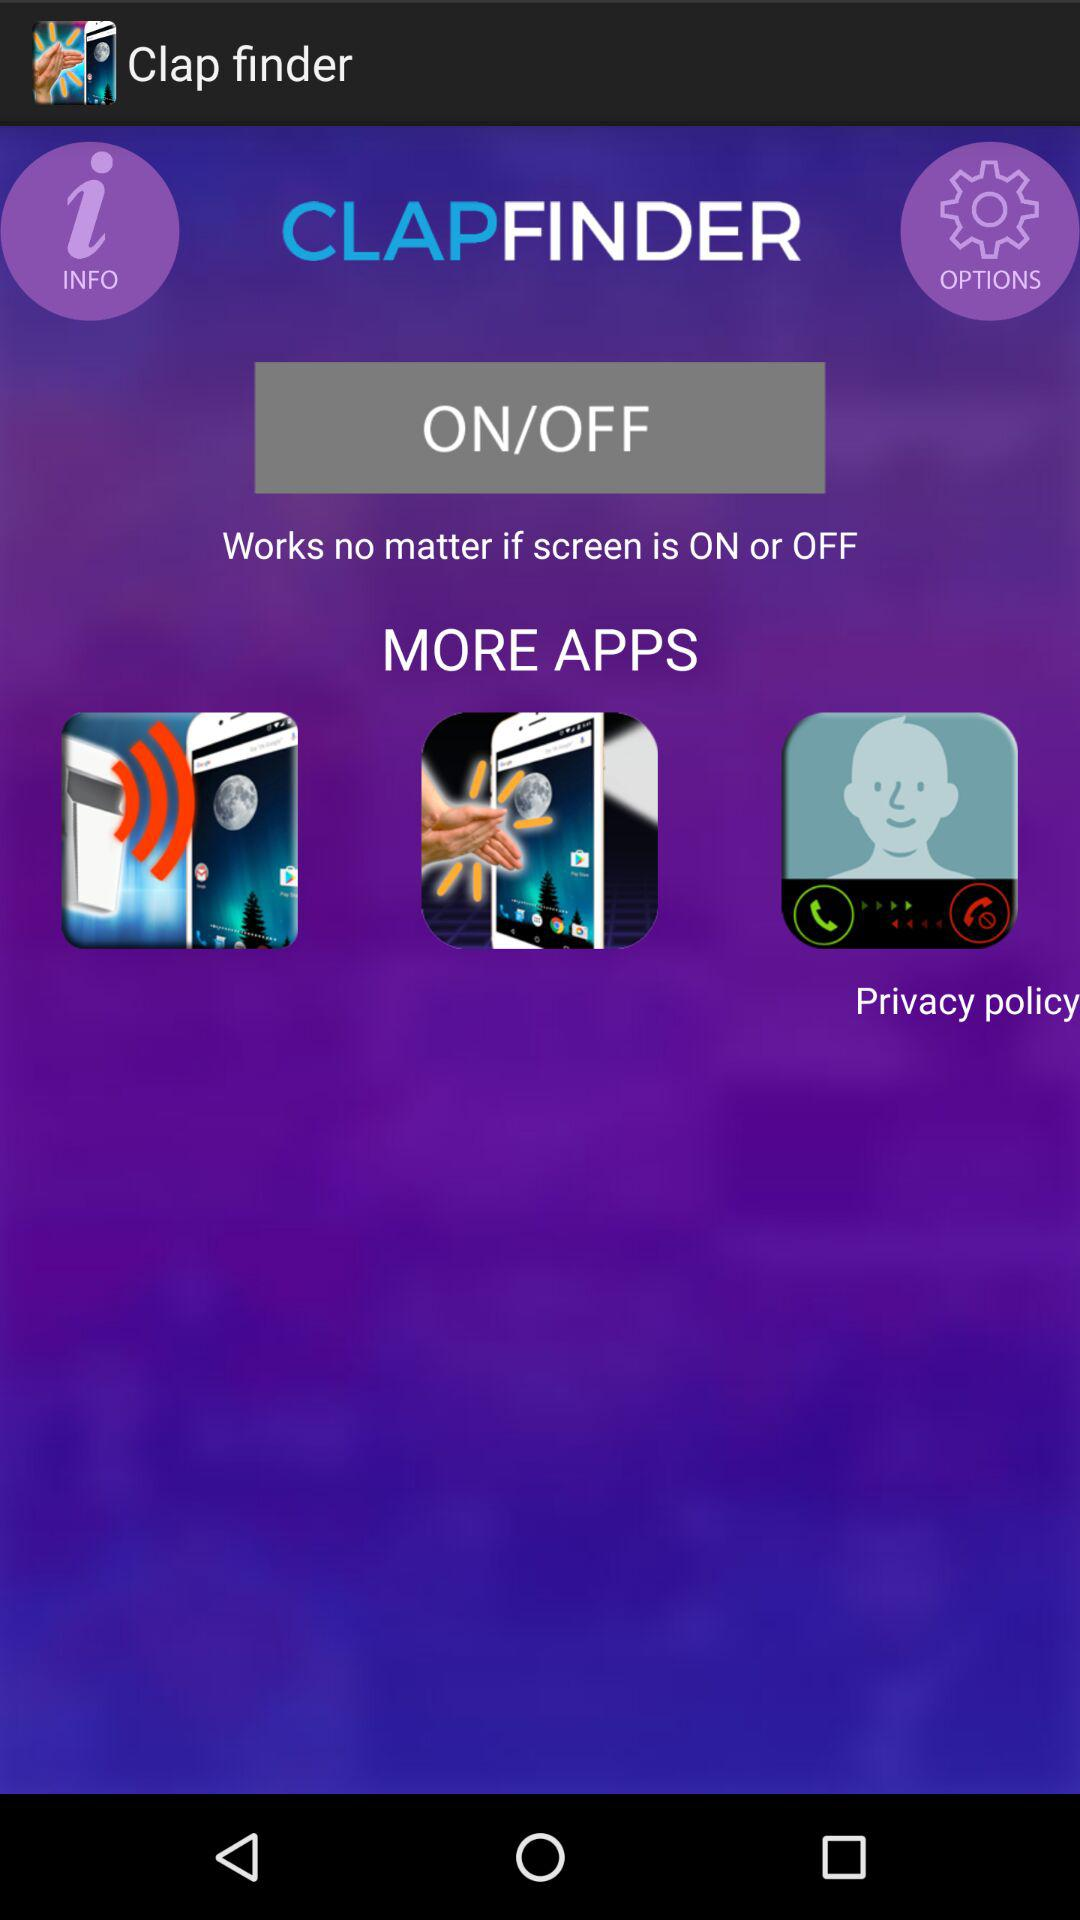What is the name of the application? The name of the application is "Clap finder". 